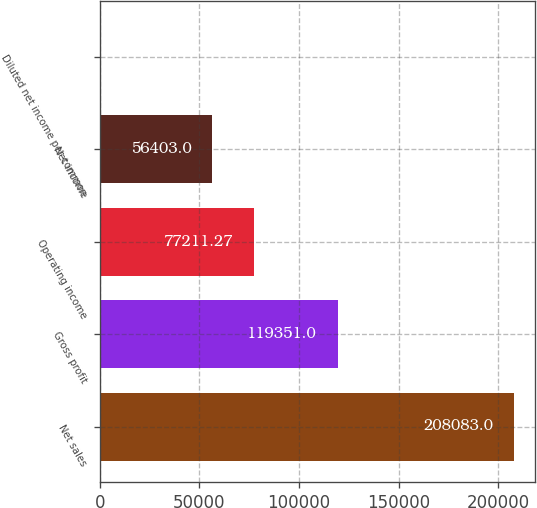Convert chart. <chart><loc_0><loc_0><loc_500><loc_500><bar_chart><fcel>Net sales<fcel>Gross profit<fcel>Operating income<fcel>Net income<fcel>Diluted net income per common<nl><fcel>208083<fcel>119351<fcel>77211.3<fcel>56403<fcel>0.27<nl></chart> 